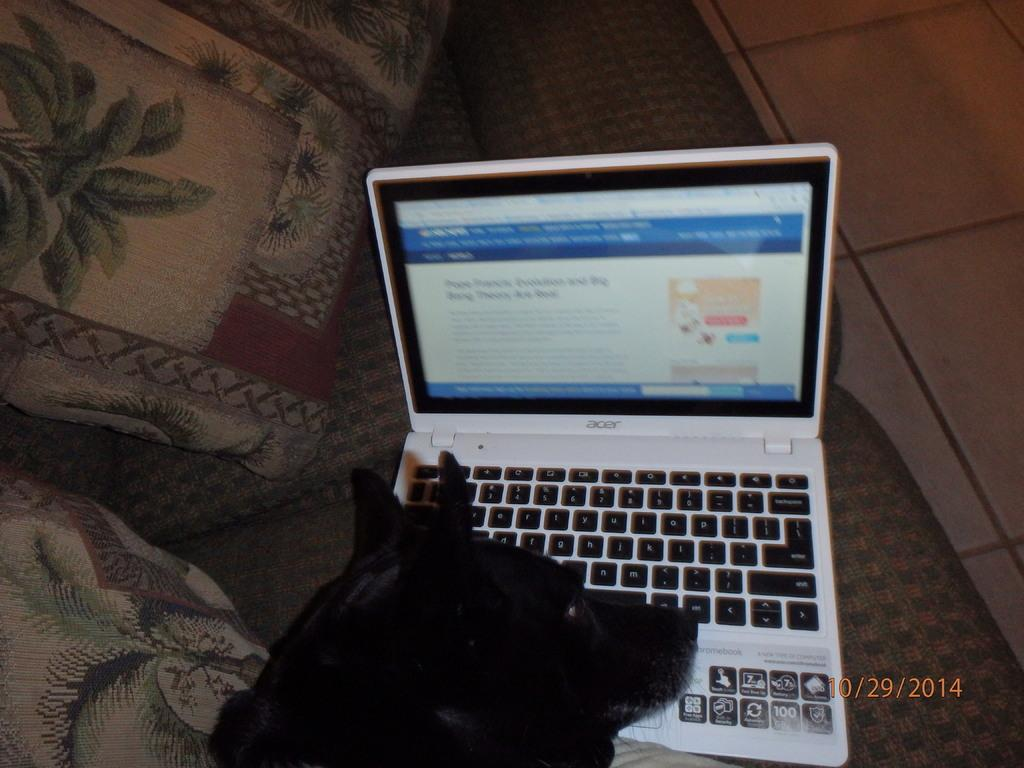<image>
Write a terse but informative summary of the picture. An ACER laptop sits open and a black dog is resting his head on the keyboard 